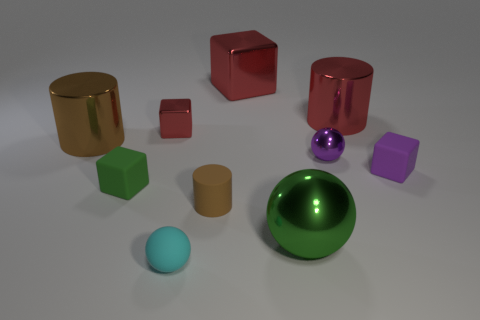There is a cube that is on the right side of the red metallic cylinder; is it the same color as the tiny metallic sphere?
Ensure brevity in your answer.  Yes. There is a large metal thing left of the tiny green cube; is it the same color as the tiny cylinder that is right of the cyan matte sphere?
Your answer should be very brief. Yes. There is a tiny object that is the same color as the big sphere; what shape is it?
Your answer should be very brief. Cube. There is a small purple thing that is the same shape as the large green shiny object; what is it made of?
Offer a terse response. Metal. There is a sphere that is the same size as the purple metal object; what color is it?
Provide a short and direct response. Cyan. Are there an equal number of large brown things that are behind the tiny matte sphere and small brown matte cylinders?
Provide a short and direct response. Yes. The large block that is to the left of the big cylinder that is right of the tiny red metallic thing is what color?
Make the answer very short. Red. There is a red metal object that is right of the metallic sphere that is left of the purple ball; what size is it?
Offer a terse response. Large. What size is the cylinder that is the same color as the large metallic block?
Offer a terse response. Large. How many other objects are the same size as the brown shiny object?
Offer a very short reply. 3. 